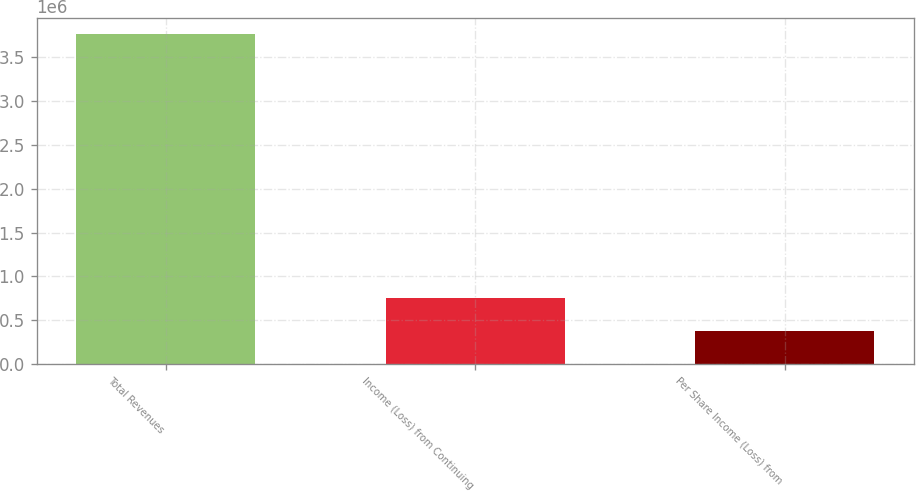Convert chart. <chart><loc_0><loc_0><loc_500><loc_500><bar_chart><fcel>Total Revenues<fcel>Income (Loss) from Continuing<fcel>Per Share Income (Loss) from<nl><fcel>3.76393e+06<fcel>752786<fcel>376393<nl></chart> 